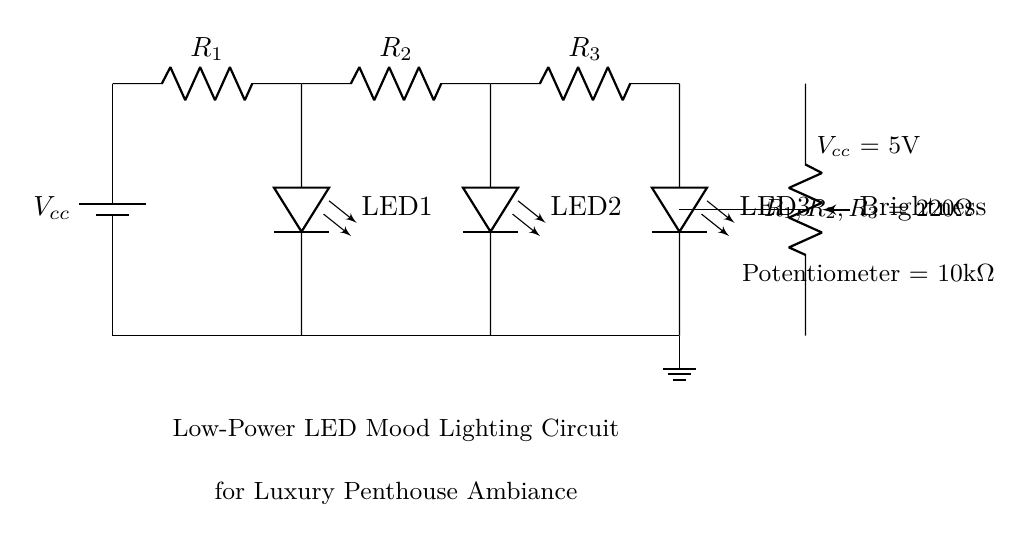What is the total resistance of the resistor network? The resistors R1, R2, and R3 are in series. The total resistance can be calculated by summing their values: R_total = R1 + R2 + R3 = 220Ω + 220Ω + 220Ω = 660Ω.
Answer: 660Ω What is the purpose of the potentiometer in this circuit? The potentiometer is used for brightness control. It adjusts the resistance in the circuit, which in turn varies the amount of current flowing through the LEDs, affecting their brightness.
Answer: Brightness control How many LEDs are present in this circuit? The circuit diagram shows three LED components labeled LED1, LED2, and LED3.
Answer: 3 What is the operating voltage of the circuit? The battery labeled Vcc provides the operating voltage, which is 5V. This is the voltage supply for the entire circuit.
Answer: 5V What type of circuit is this? This circuit is a low-power LED mood lighting circuit. It is designed to provide aesthetic lighting while consuming minimal power.
Answer: Low-power LED mood lighting What would happen if you increase the value of the potentiometer? Increasing the value of the potentiometer will increase the resistance in the circuit, thereby reducing the current flowing through the LEDs. This will result in lower brightness of the LEDs.
Answer: Reduced brightness 